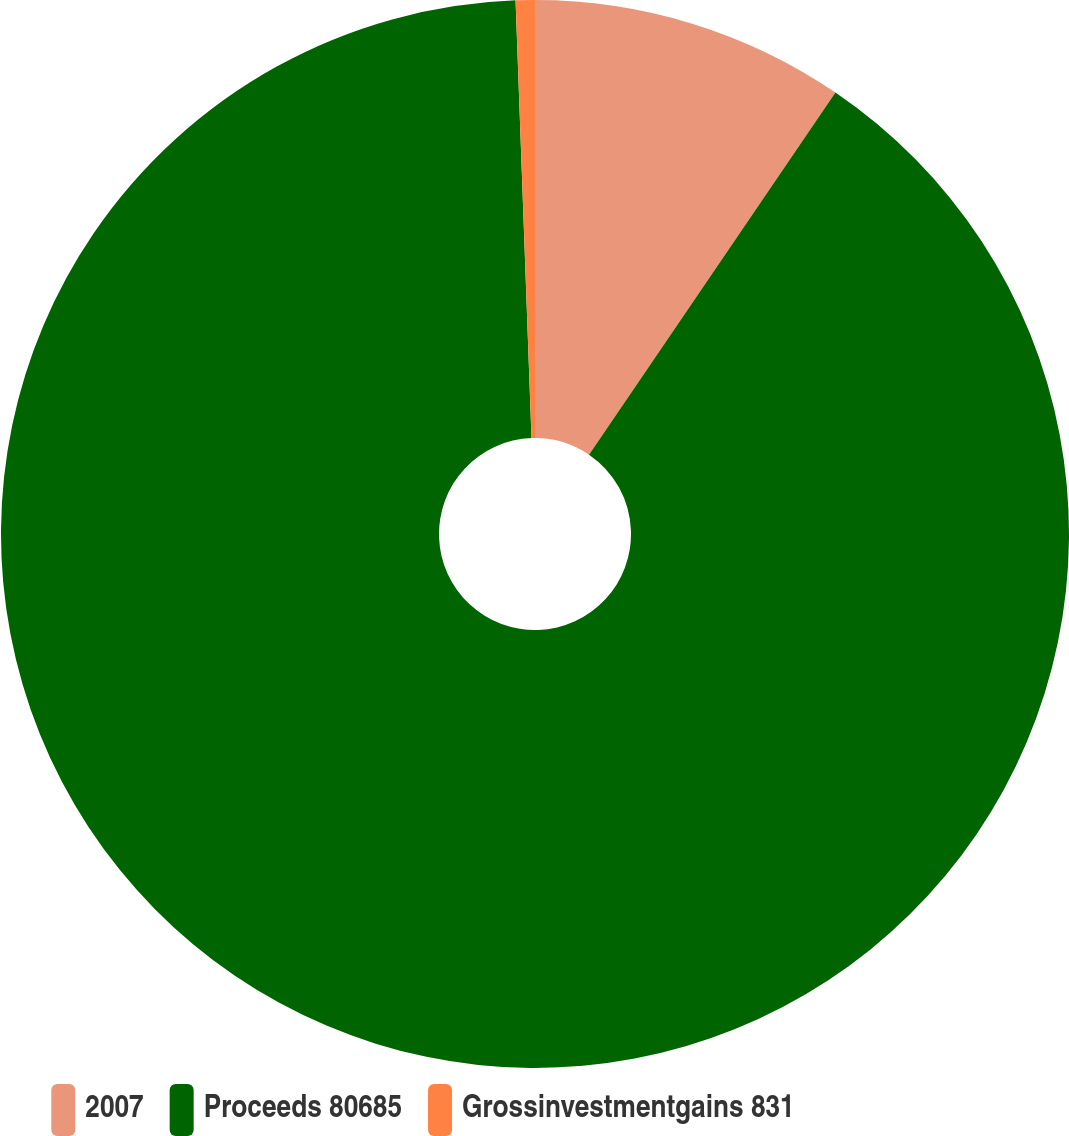Convert chart. <chart><loc_0><loc_0><loc_500><loc_500><pie_chart><fcel>2007<fcel>Proceeds 80685<fcel>Grossinvestmentgains 831<nl><fcel>9.51%<fcel>89.91%<fcel>0.58%<nl></chart> 